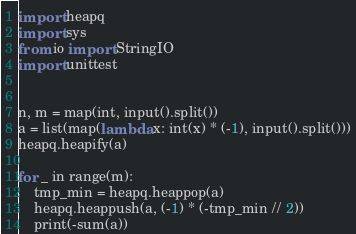<code> <loc_0><loc_0><loc_500><loc_500><_Python_>import heapq
import sys
from io import StringIO
import unittest


n, m = map(int, input().split())
a = list(map(lambda x: int(x) * (-1), input().split()))
heapq.heapify(a)

for _ in range(m):
	tmp_min = heapq.heappop(a)
	heapq.heappush(a, (-1) * (-tmp_min // 2))
	print(-sum(a))</code> 